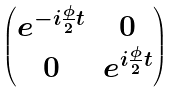<formula> <loc_0><loc_0><loc_500><loc_500>\begin{pmatrix} e ^ { - i \frac { \phi } { 2 } t } & 0 \\ 0 & e ^ { i \frac { \phi } { 2 } t } \end{pmatrix}</formula> 